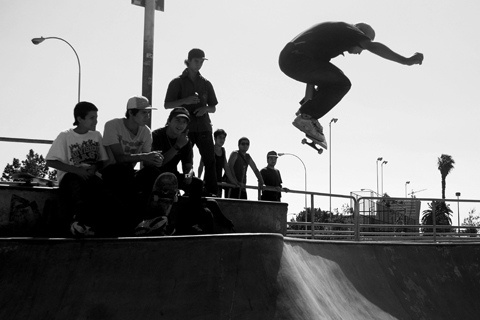Describe the objects in this image and their specific colors. I can see people in lightgray, black, gray, and darkgray tones, people in lightgray, black, gray, and darkgray tones, people in lightgray, black, gray, and darkgray tones, people in lightgray, black, gray, and darkgray tones, and people in lightgray, black, gray, white, and darkgray tones in this image. 